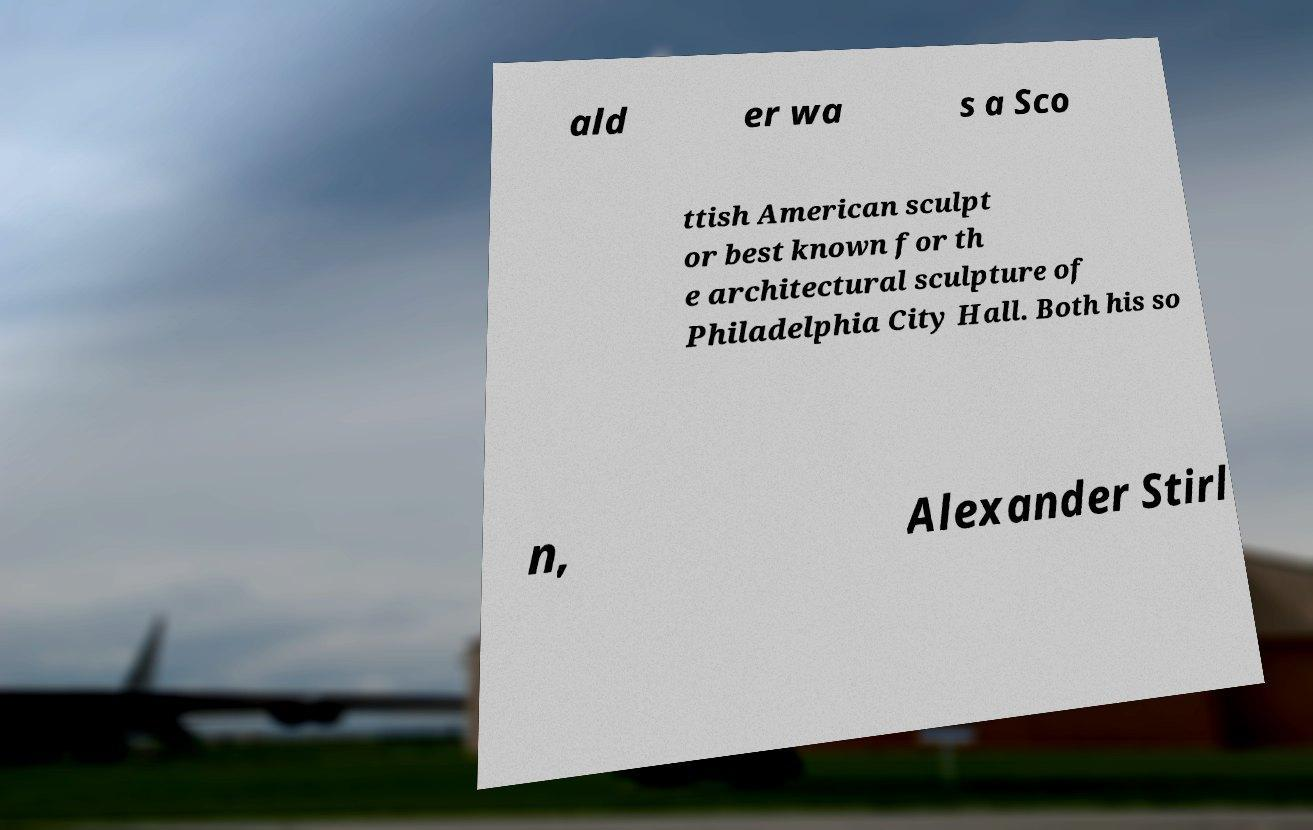There's text embedded in this image that I need extracted. Can you transcribe it verbatim? ald er wa s a Sco ttish American sculpt or best known for th e architectural sculpture of Philadelphia City Hall. Both his so n, Alexander Stirl 